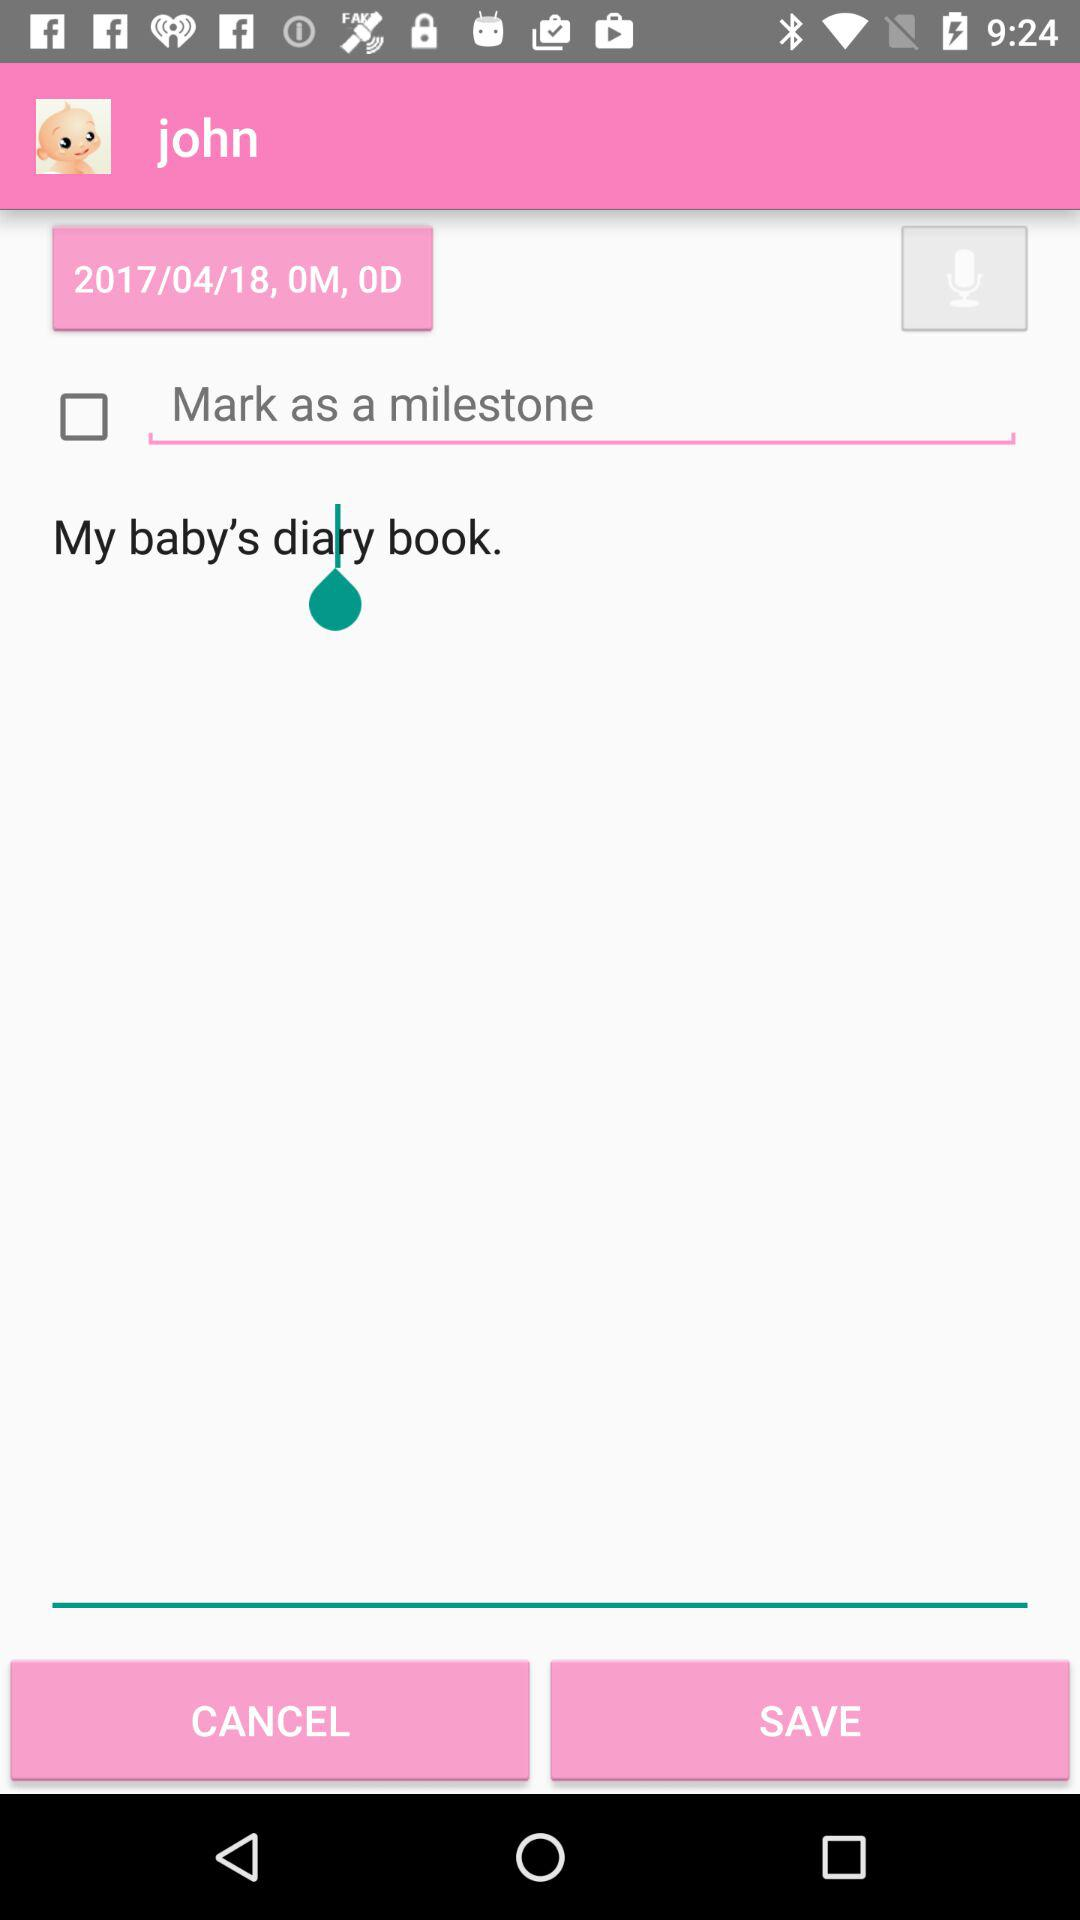What is the name of the user? The name of the user is John. 